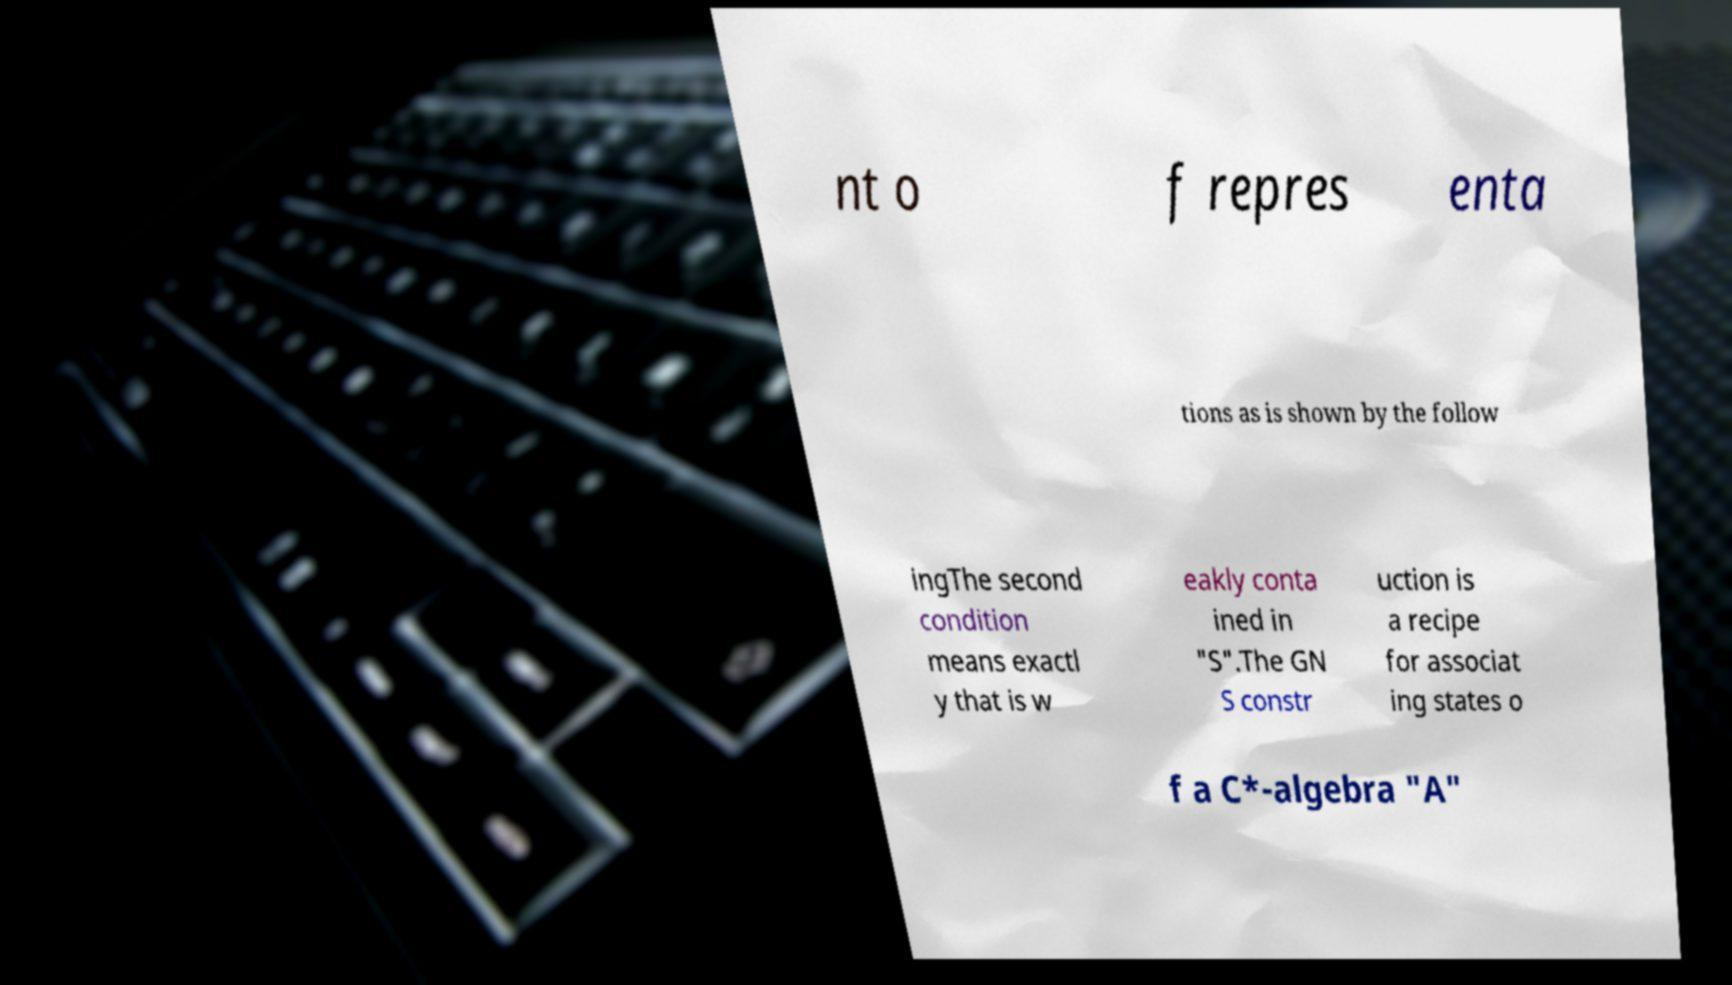Could you assist in decoding the text presented in this image and type it out clearly? nt o f repres enta tions as is shown by the follow ingThe second condition means exactl y that is w eakly conta ined in "S".The GN S constr uction is a recipe for associat ing states o f a C*-algebra "A" 